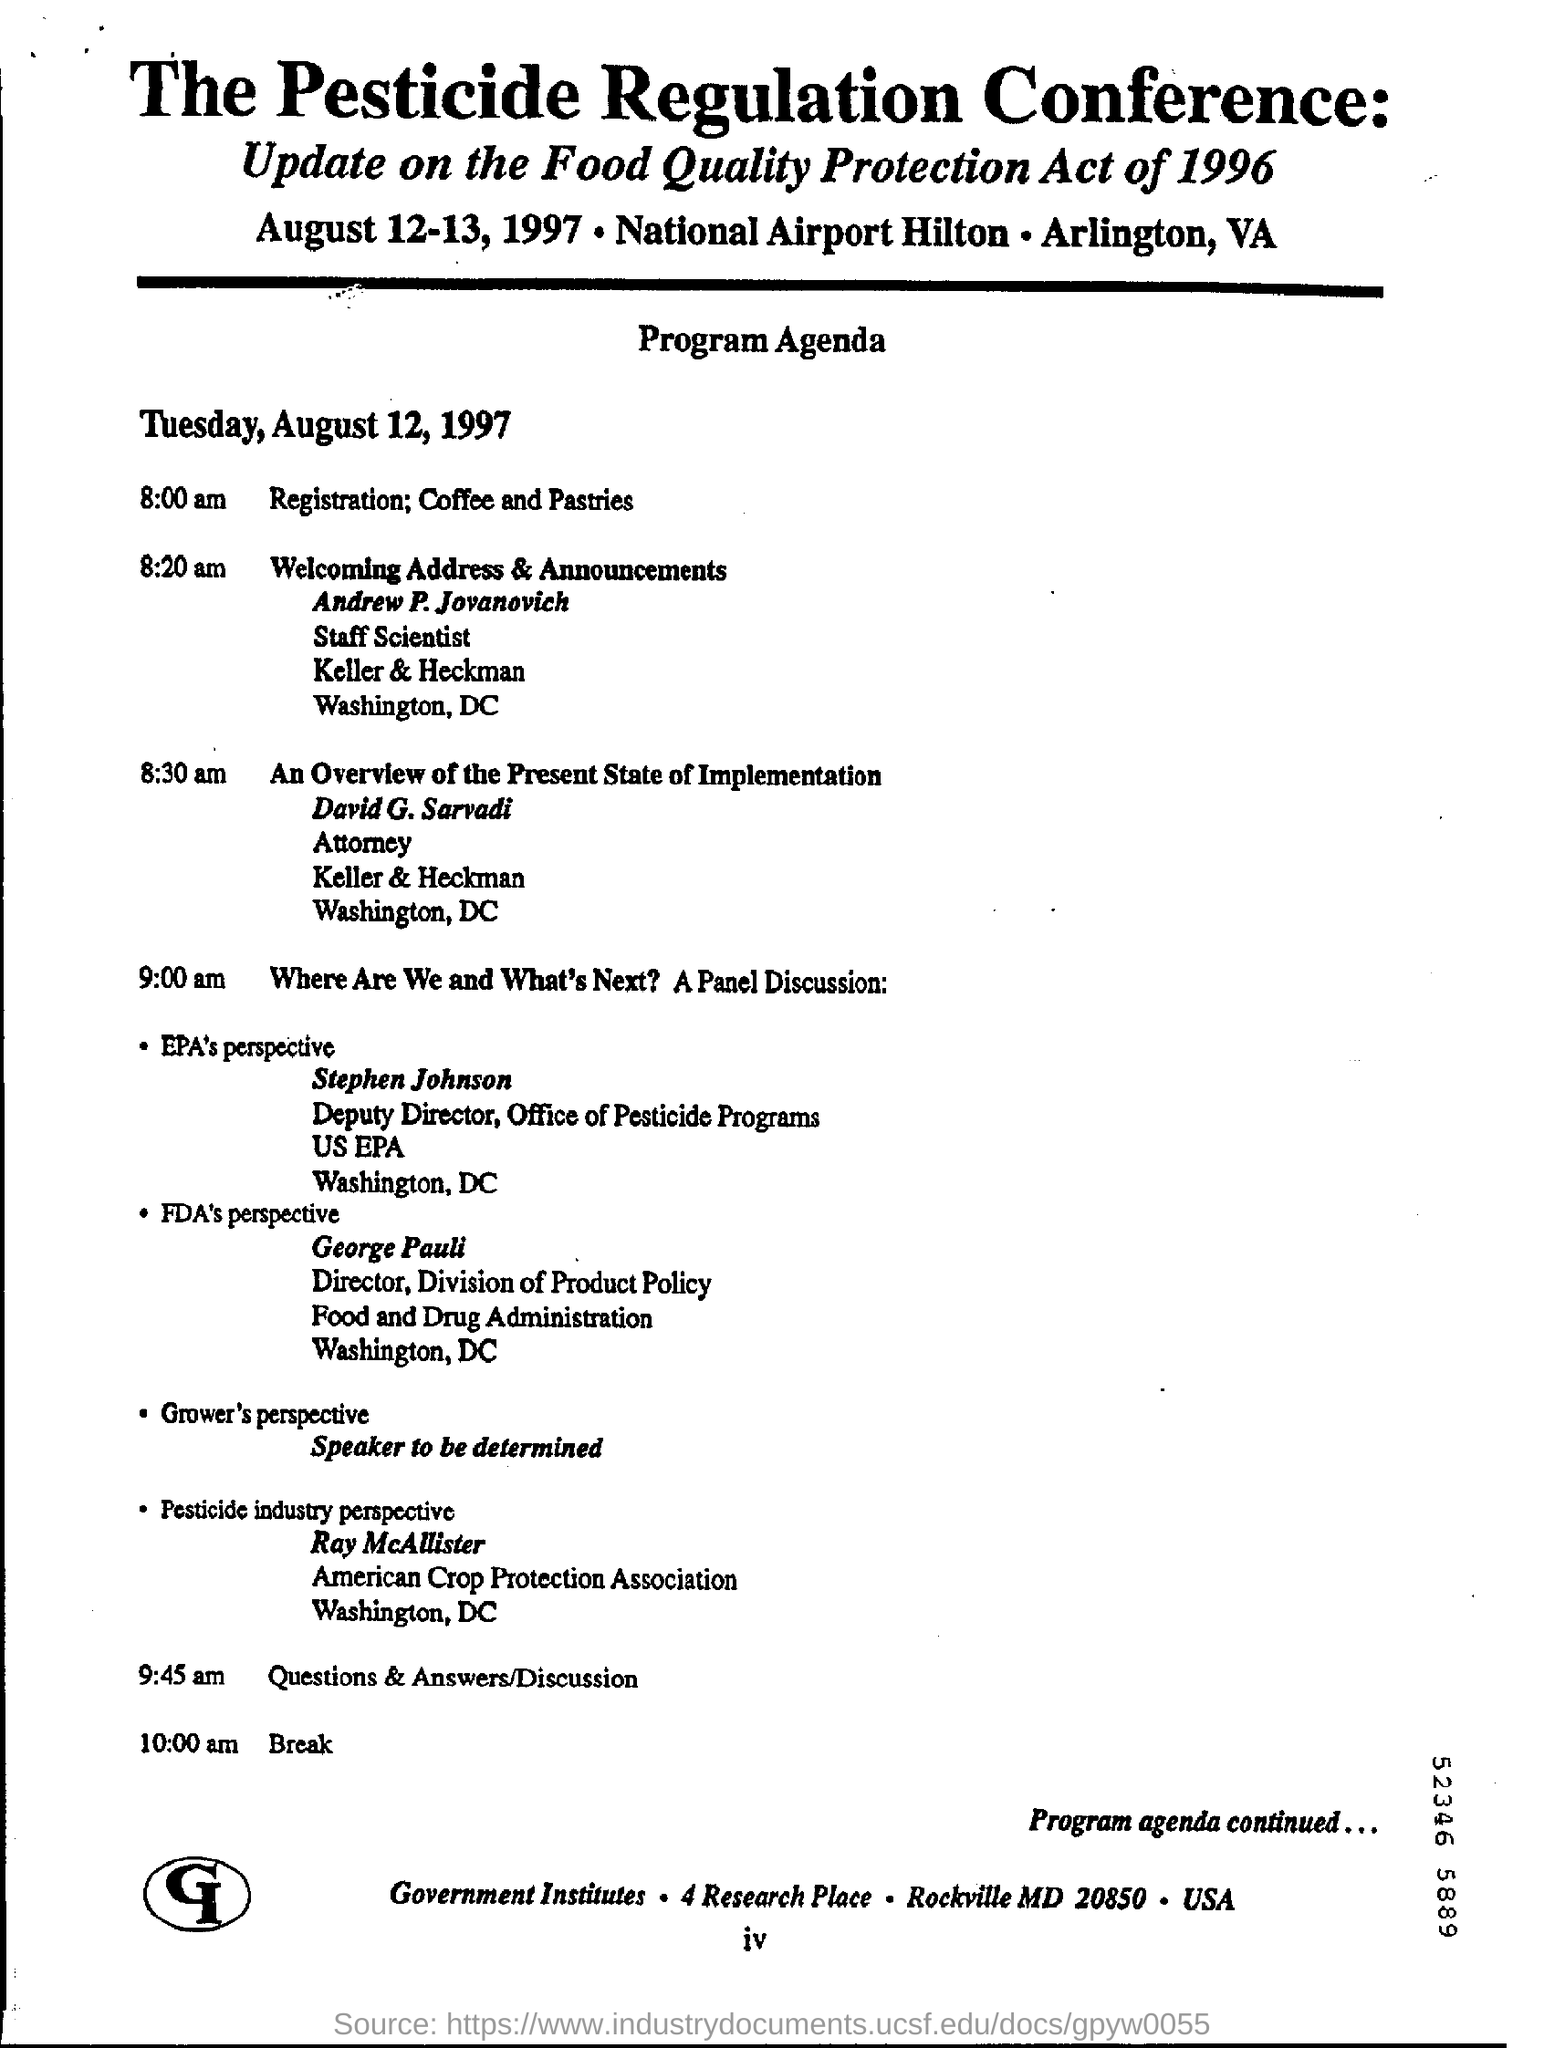What is the name of the conference?
Keep it short and to the point. The Pesticide Regulation Conference. When is the registration starting?
Keep it short and to the point. 8:00 am. Who is Andrew P. Jovanovich?
Make the answer very short. Staff Scientist. What is the event scheduled at 9:45 am?
Ensure brevity in your answer.  Questions & Answers/Discussion. 